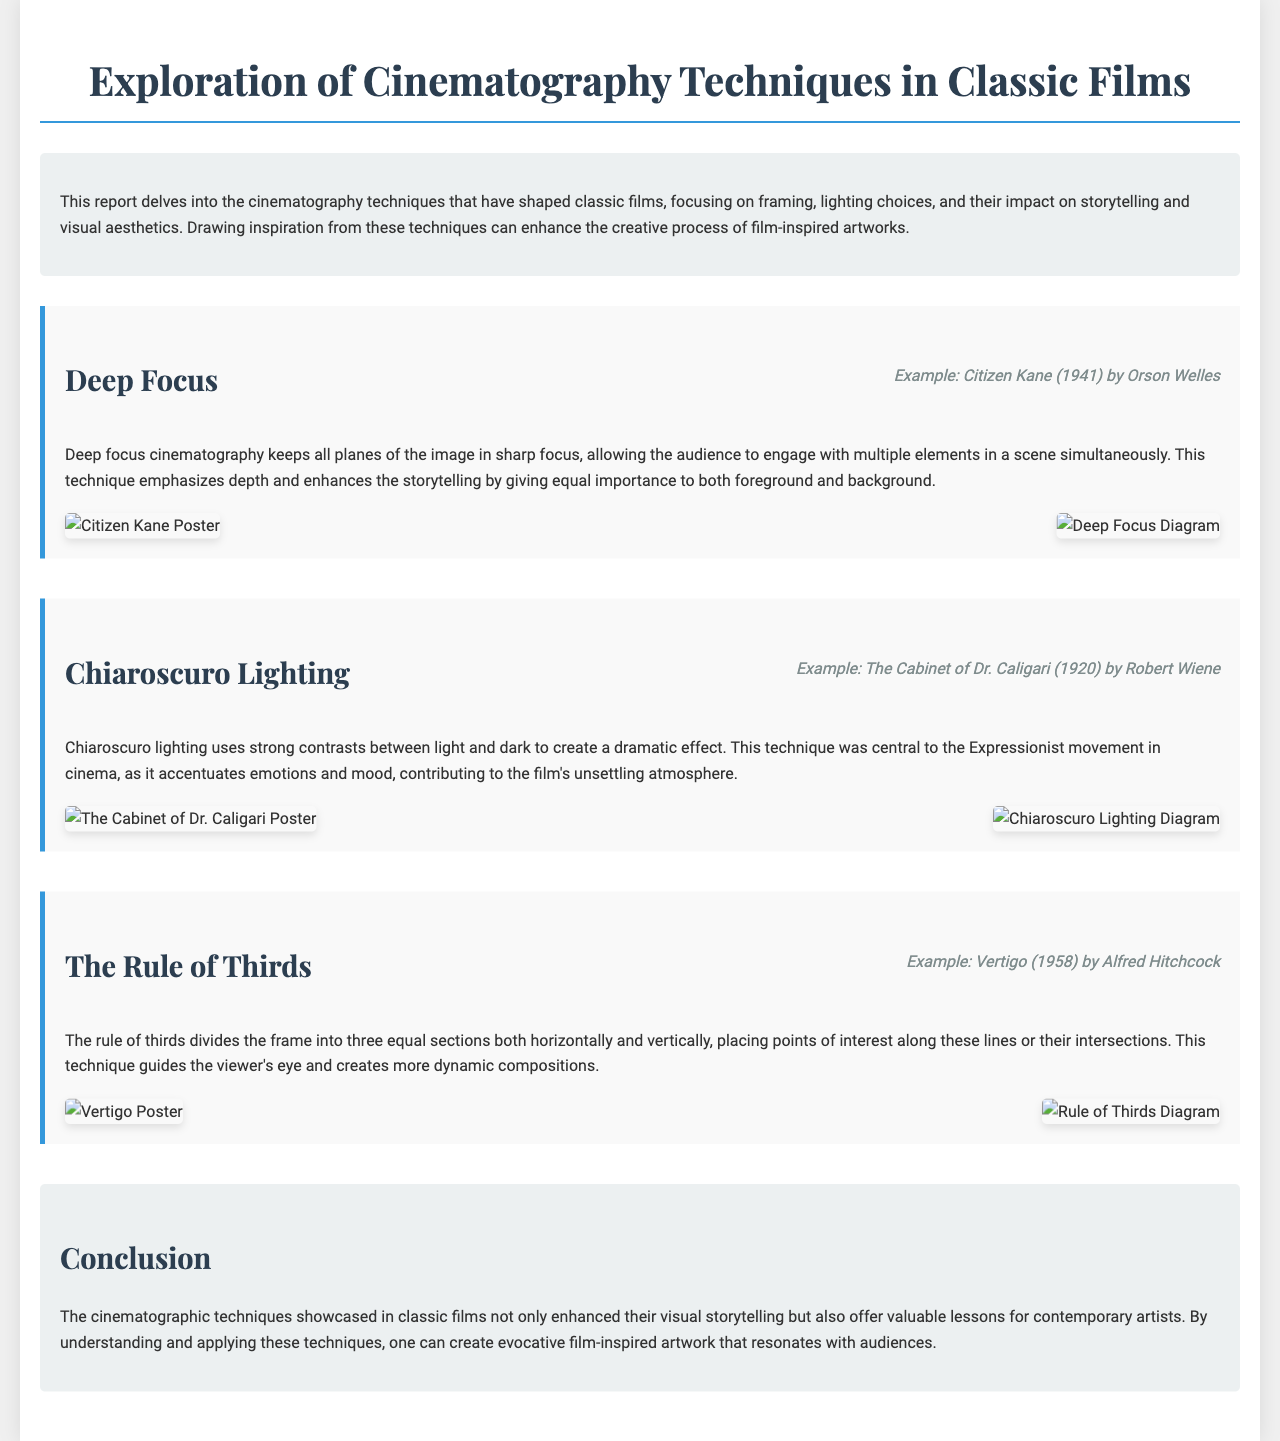What is the title of the report? The title of the report is presented at the top of the document.
Answer: Exploration of Cinematography Techniques in Classic Films Who directed "Citizen Kane"? The director of "Citizen Kane" is mentioned in the example film for deep focus cinematography.
Answer: Orson Welles What year was "The Cabinet of Dr. Caligari" released? The year of release for "The Cabinet of Dr. Caligari" is specified in the film example section.
Answer: 1920 Which cinematography technique emphasizes depth? The technique that emphasizes depth is described in the section discussing its principles.
Answer: Deep Focus What is the purpose of chiaroscuro lighting in films? The report explains that chiaroscuro lighting creates dramatic effects by using light and dark contrasts.
Answer: Dramatic effect How does the rule of thirds affect composition? The rule of thirds is described as guiding the viewer's eye to create dynamic compositions.
Answer: Guides viewer's eye What are the two main elements analyzed in the report? The report focuses on specific elements of cinematography that influence films.
Answer: Framing and lighting What is the key takeaway mentioned in the conclusion? The conclusion highlights the value of understanding cinematographic techniques for contemporary artists.
Answer: Valuable lessons for contemporary artists 